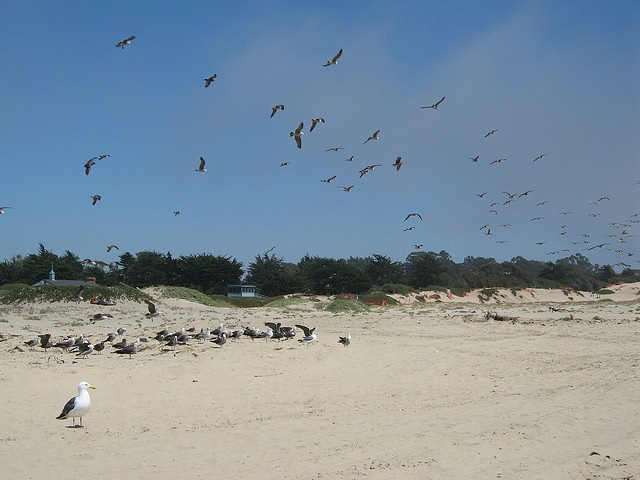Describe the objects in this image and their specific colors. I can see bird in gray, black, and darkgray tones, bird in gray, lightgray, darkgray, and black tones, bird in gray and black tones, bird in gray and black tones, and bird in gray, black, darkgray, and lightgray tones in this image. 